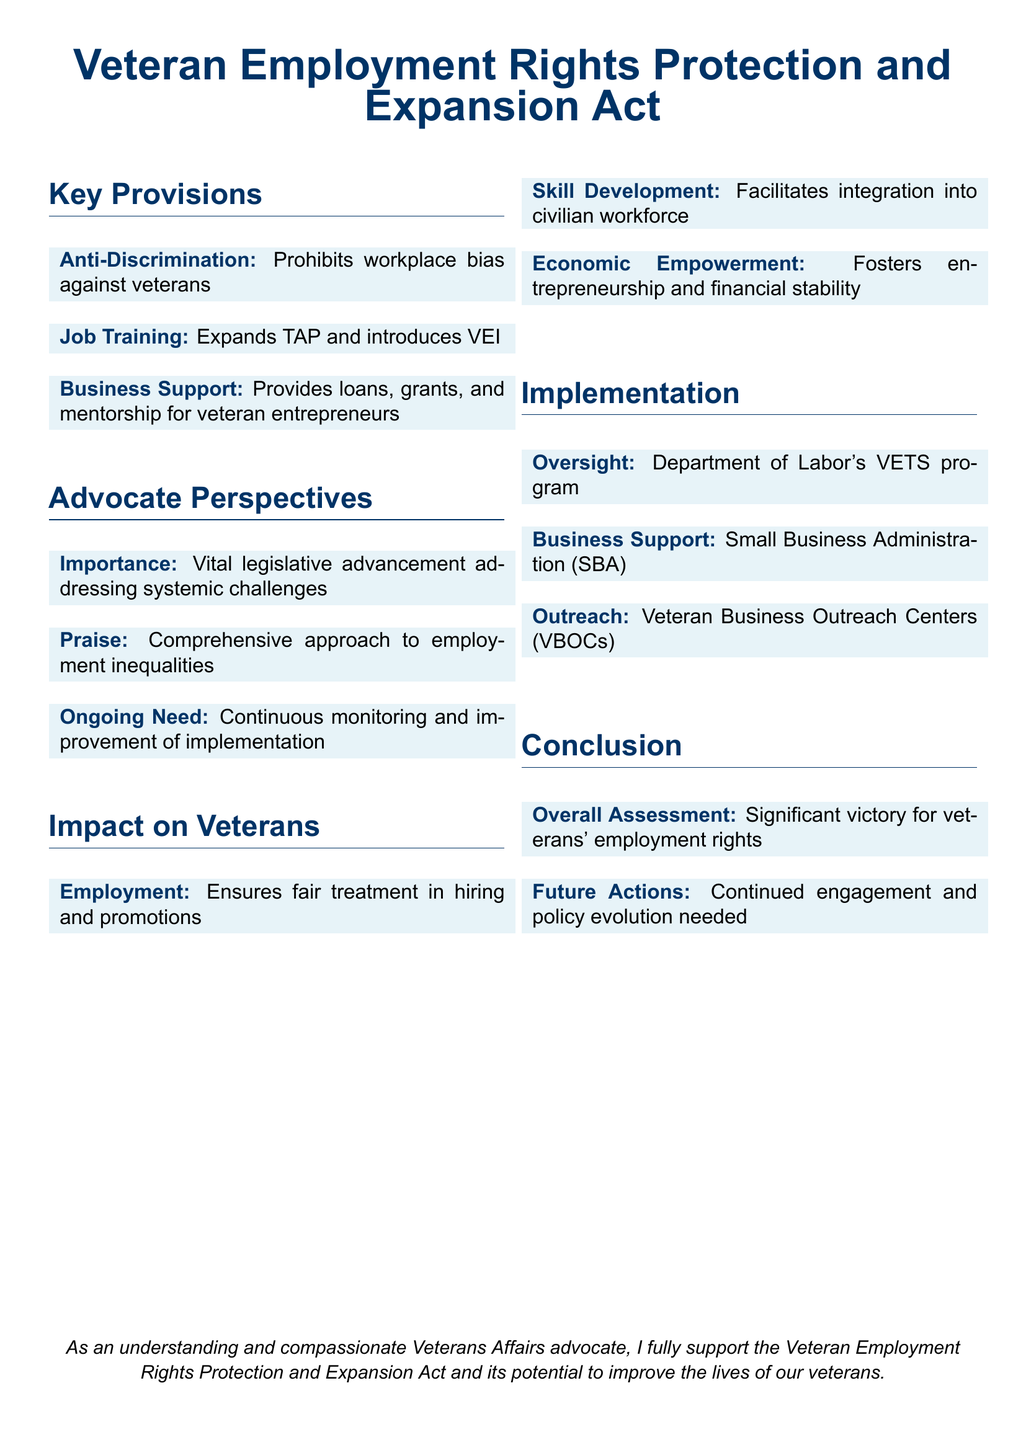What is prohibited under the Act? The document states that the Act prohibits workplace bias against veterans.
Answer: Workplace bias What does TAP stand for in the context of job training? TAP stands for Transition Assistance Program, which is expanded by the Act.
Answer: Transition Assistance Program Which program is overseen by the Department of Labor? The VETS program, which focuses on veteran employment, is overseen by the Department of Labor.
Answer: VETS program What type of support does the Small Business Administration provide? According to the document, the Small Business Administration provides business support to veterans.
Answer: Business support What is highlighted as a vital aspect of the legislation? The importance of addressing systemic challenges faced by veterans is emphasized in the document.
Answer: Addressing systemic challenges What is the main goal of the veteran-owned business support? The document indicates that the goal is to provide loans, grants, and mentorship.
Answer: Loans, grants, and mentorship How is the employment impact described in the document? The document states that it ensures fair treatment in hiring and promotions for veterans.
Answer: Fair treatment What does the Act foster for veterans on an economic level? The document states that the Act fosters entrepreneurship and financial stability for veterans.
Answer: Entrepreneurship and financial stability 